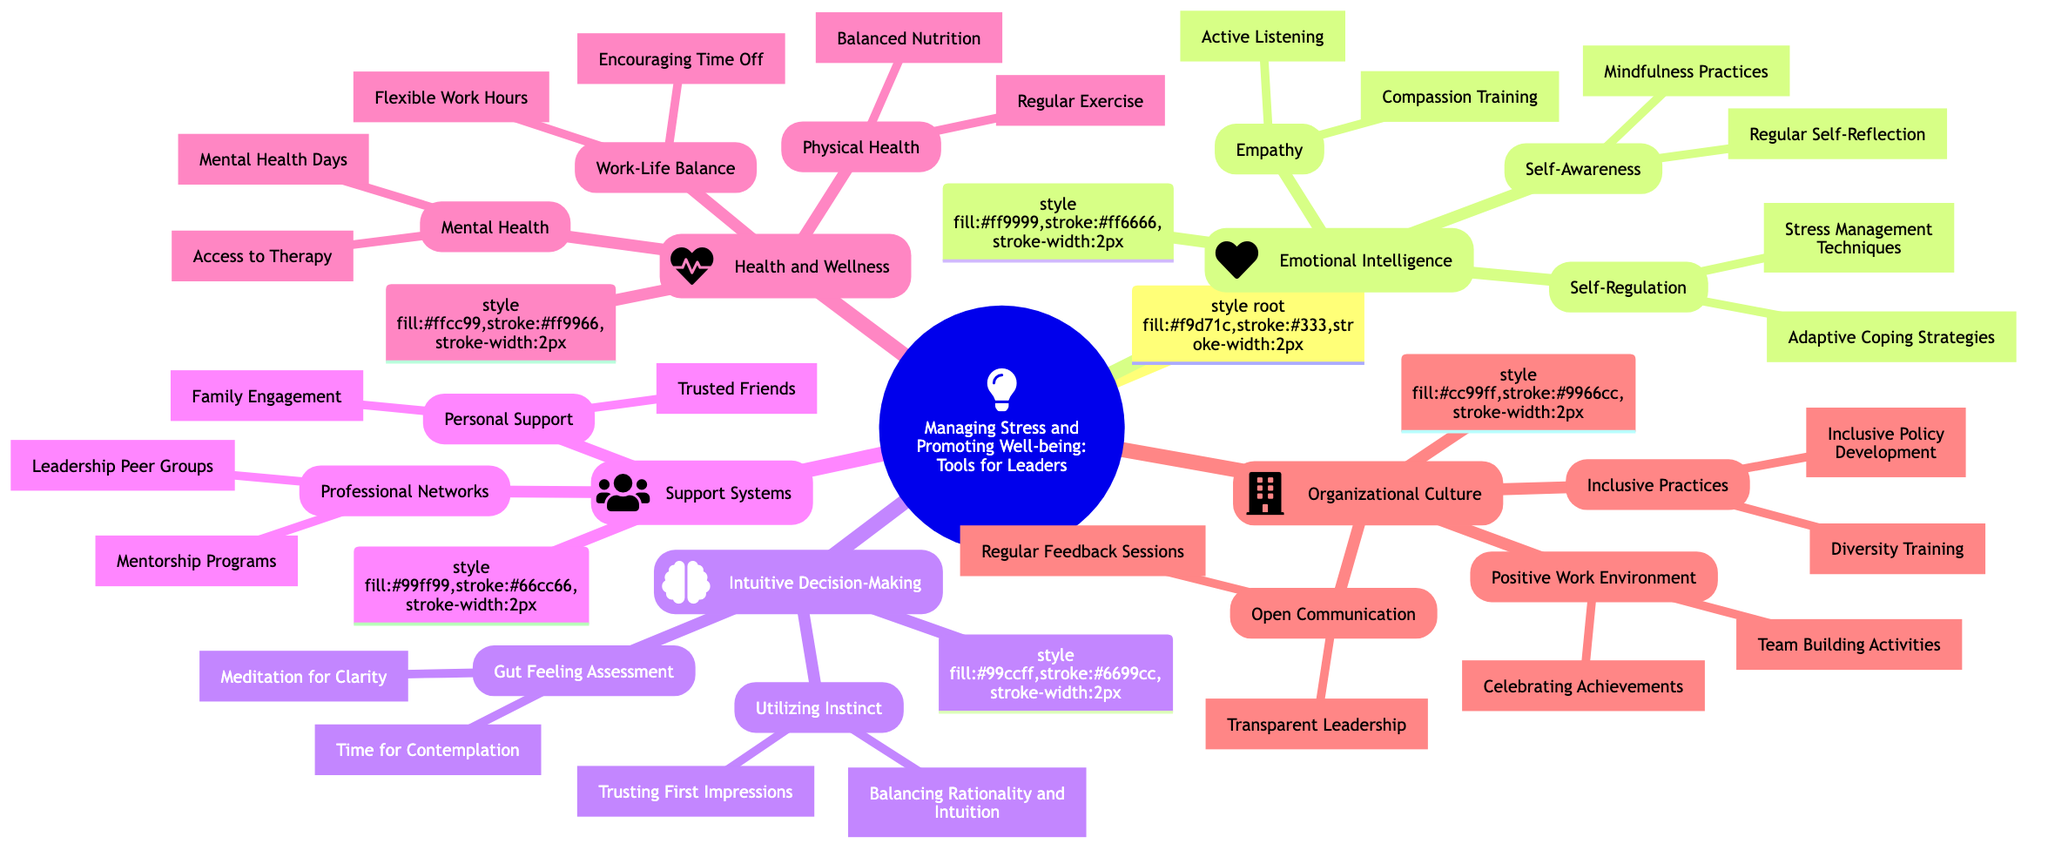What is the main focus of the mind map? The main focus is explicitly stated at the root of the mind map. By looking at the title, it is clear that the focus is on "Managing Stress and Promoting Well-being: Tools for Leaders."
Answer: Managing Stress and Promoting Well-being: Tools for Leaders How many subtopics are listed under "Emotional Intelligence"? To determine the number of subtopics under "Emotional Intelligence," we count the specific subtopic nodes: Self-Awareness, Empathy, and Self-Regulation, totaling three.
Answer: 3 What practices are mentioned under "Gut Feeling Assessment"? The practices listed under "Gut Feeling Assessment" are provided in the sub-nodes: "Meditation for Clarity" and "Time for Contemplation." By looking at these sub-nodes, we identify them as the relevant practices.
Answer: Meditation for Clarity, Time for Contemplation Which element includes "Inclusivity Training"? "Inclusivity Training" falls under "Inclusive Practices," a subtopic of "Organizational Culture." Therefore, we trace back to see that it pertains to the "Organizational Culture" element.
Answer: Organizational Culture What are the two aspects under "Health and Wellness"? The section on "Health and Wellness" provides three distinct aspects: Physical Health, Mental Health, and Work-Life Balance. We list these to answer the question directly about the provided aspects.
Answer: Physical Health, Mental Health, Work-Life Balance How does the mind map organize the tools for leaders? The tools are organized into five main thematic categories: Emotional Intelligence, Intuitive Decision-Making, Support Systems, Health and Wellness, and Organizational Culture. Each main focus has its own nodes and sub-nodes detailing specific tools.
Answer: Five main thematic categories What is a strategy listed under "Personal Support"? The strategy mentioned under "Personal Support" is "Family Engagement" and "Trusted Friends." Both of these strategies are clearly outlined within the sub-nodes of "Personal Support."
Answer: Family Engagement, Trusted Friends What is the total number of nodes under "Support Systems"? Under "Support Systems," we count the subtopics: Professional Networks, which has two sub-nodes, and Personal Support, which has two sub-nodes. Thus, there are a total of four nodes under "Support Systems."
Answer: 4 Which two aspects under "Work-Life Balance" promote employee well-being? Under "Work-Life Balance," the relevant aspects promoting employee well-being include "Flexible Work Hours" and "Encouraging Time Off." These strategies aim to improve well-being in the workplace.
Answer: Flexible Work Hours, Encouraging Time Off 